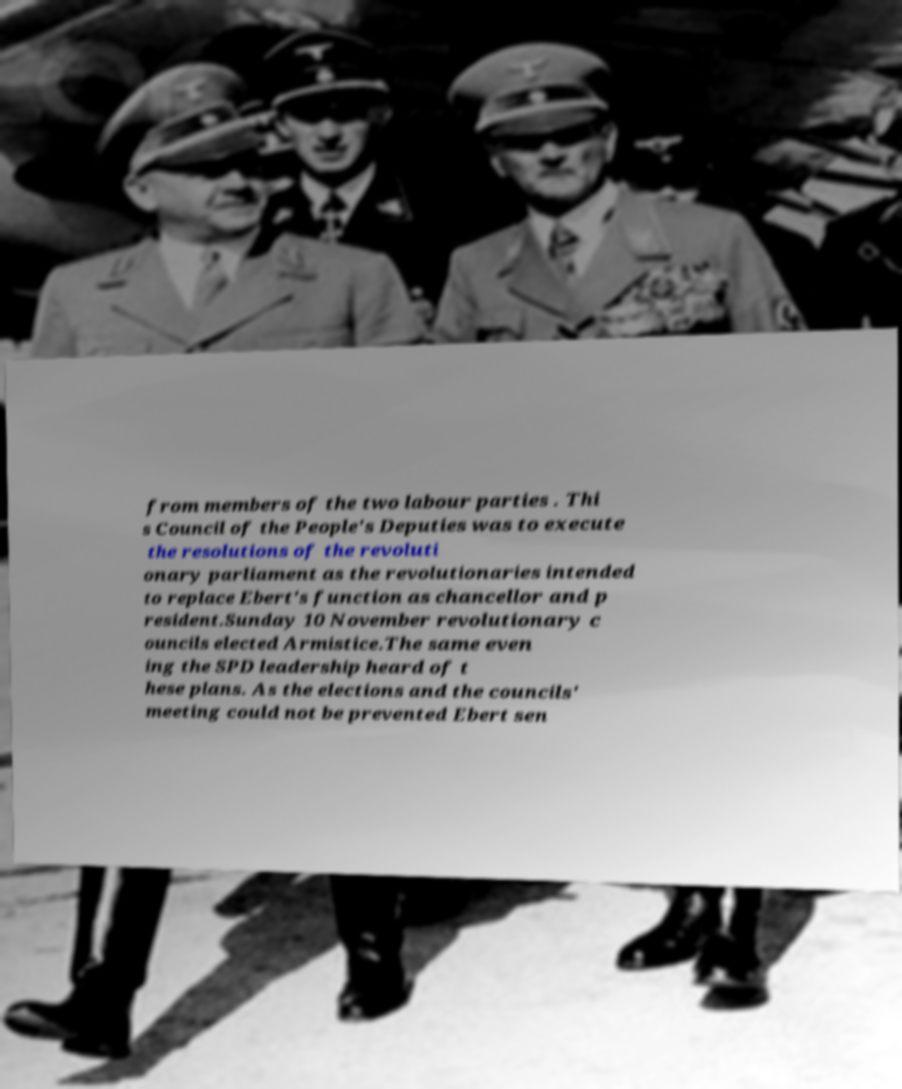Can you accurately transcribe the text from the provided image for me? from members of the two labour parties . Thi s Council of the People's Deputies was to execute the resolutions of the revoluti onary parliament as the revolutionaries intended to replace Ebert's function as chancellor and p resident.Sunday 10 November revolutionary c ouncils elected Armistice.The same even ing the SPD leadership heard of t hese plans. As the elections and the councils' meeting could not be prevented Ebert sen 